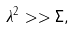<formula> <loc_0><loc_0><loc_500><loc_500>\lambda ^ { 2 } > > \Sigma ,</formula> 